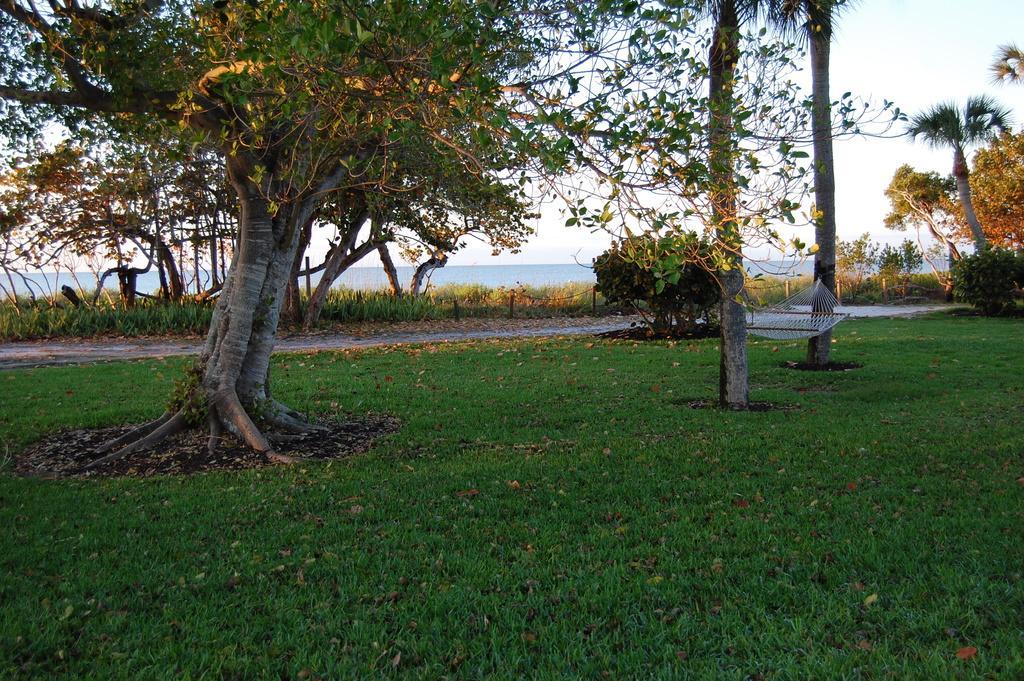Please provide a concise description of this image. In this image we can see a grassy land at the bottom of the image. There are many trees and plants in the image. We can see an ocean at the center of the image. 